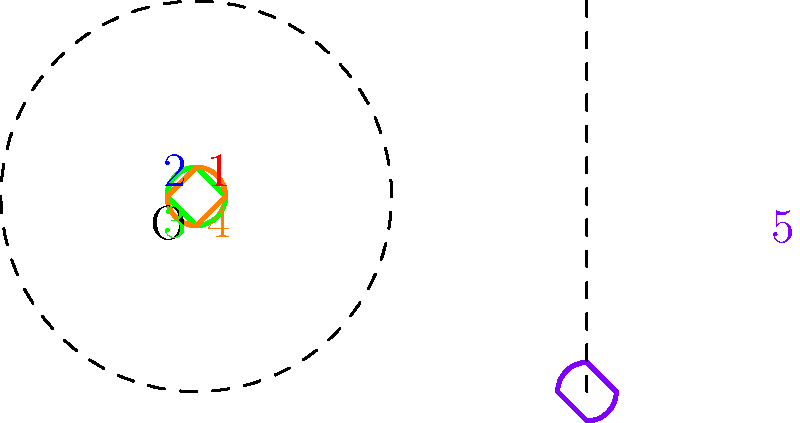A love letter emoji undergoes a series of transformations in a dating app interface. It starts at position 1 (red) and rotates 90° counterclockwise around point O three times, creating positions 2 (blue), 3 (green), and 4 (orange). Finally, it translates 3 units right to position 5 (purple). What is the composite transformation that takes the emoji directly from position 1 to position 5? Let's break this down step-by-step:

1) First, we need to understand the total rotation:
   - The emoji rotates 90° counterclockwise three times
   - Total rotation = 3 * 90° = 270° counterclockwise
   - 270° counterclockwise is equivalent to 90° clockwise

2) Now, let's consider the translation:
   - The emoji moves 3 units to the right

3) To combine these transformations:
   - Rotation of 90° clockwise around point O
   - Translation of 3 units right

4) In transformational geometry, we typically perform rotations before translations

5) Therefore, the composite transformation can be described as:
   - Rotate 90° clockwise around point O, then translate 3 units right

This transformation takes the emoji directly from position 1 to position 5, bypassing the intermediate positions.
Answer: Rotate 90° clockwise around O, then translate 3 units right 